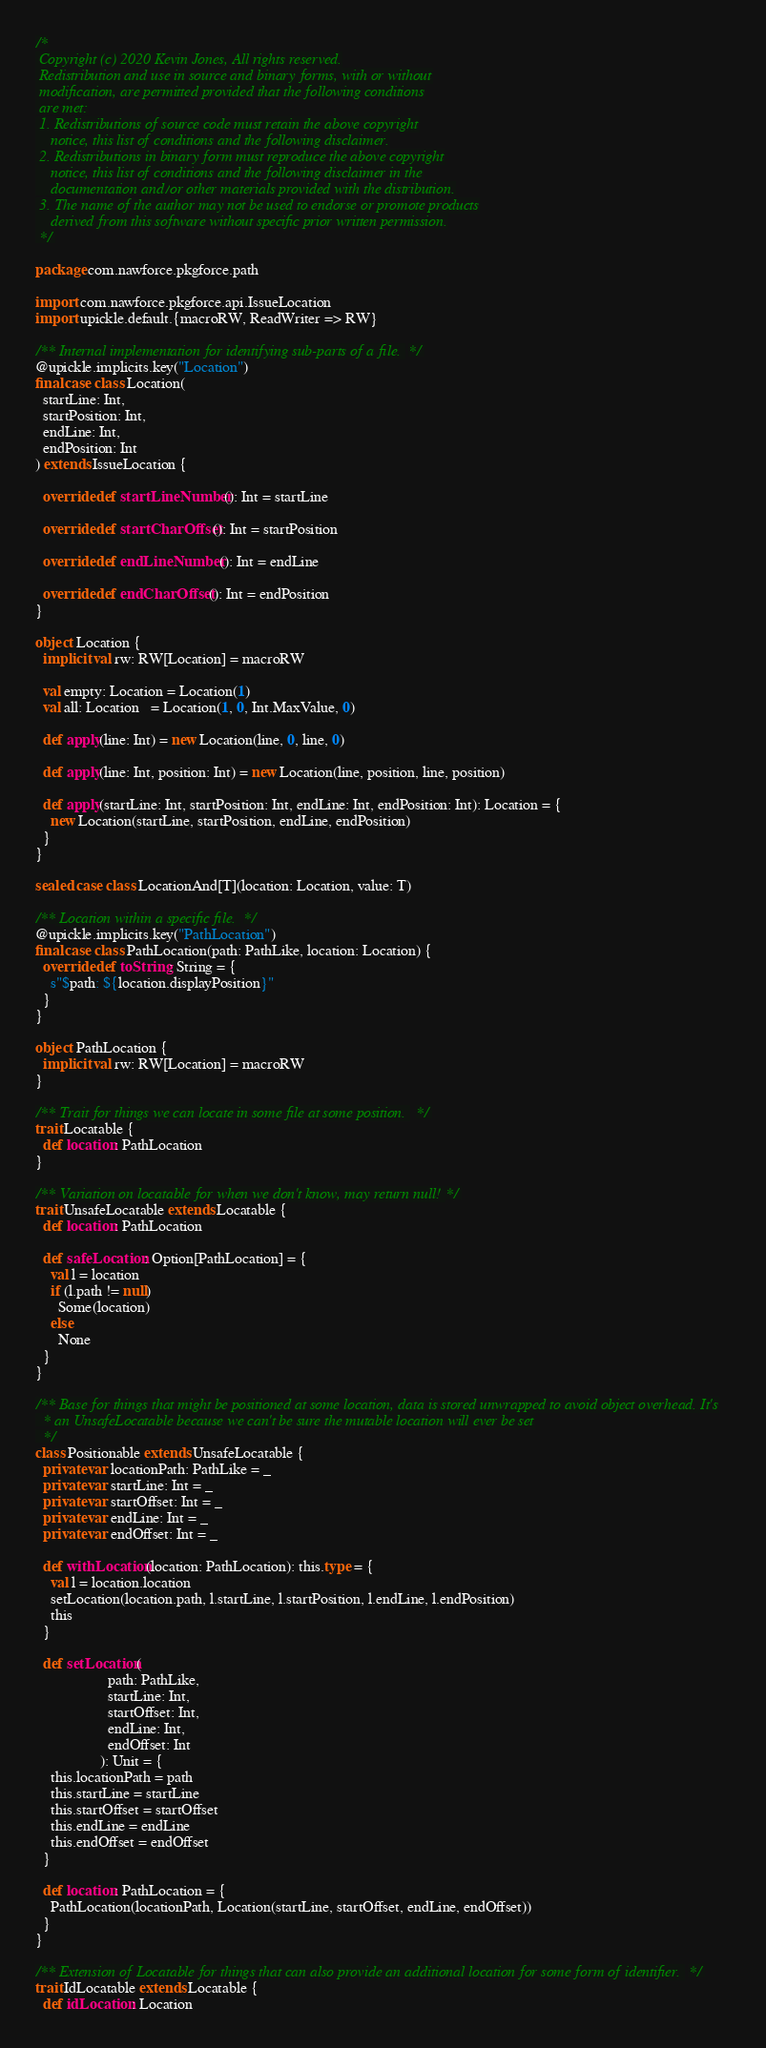Convert code to text. <code><loc_0><loc_0><loc_500><loc_500><_Scala_>/*
 Copyright (c) 2020 Kevin Jones, All rights reserved.
 Redistribution and use in source and binary forms, with or without
 modification, are permitted provided that the following conditions
 are met:
 1. Redistributions of source code must retain the above copyright
    notice, this list of conditions and the following disclaimer.
 2. Redistributions in binary form must reproduce the above copyright
    notice, this list of conditions and the following disclaimer in the
    documentation and/or other materials provided with the distribution.
 3. The name of the author may not be used to endorse or promote products
    derived from this software without specific prior written permission.
 */

package com.nawforce.pkgforce.path

import com.nawforce.pkgforce.api.IssueLocation
import upickle.default.{macroRW, ReadWriter => RW}

/** Internal implementation for identifying sub-parts of a file. */
@upickle.implicits.key("Location")
final case class Location(
  startLine: Int,
  startPosition: Int,
  endLine: Int,
  endPosition: Int
) extends IssueLocation {

  override def startLineNumber(): Int = startLine

  override def startCharOffset(): Int = startPosition

  override def endLineNumber(): Int = endLine

  override def endCharOffset(): Int = endPosition
}

object Location {
  implicit val rw: RW[Location] = macroRW

  val empty: Location = Location(1)
  val all: Location   = Location(1, 0, Int.MaxValue, 0)

  def apply(line: Int) = new Location(line, 0, line, 0)

  def apply(line: Int, position: Int) = new Location(line, position, line, position)

  def apply(startLine: Int, startPosition: Int, endLine: Int, endPosition: Int): Location = {
    new Location(startLine, startPosition, endLine, endPosition)
  }
}

sealed case class LocationAnd[T](location: Location, value: T)

/** Location within a specific file. */
@upickle.implicits.key("PathLocation")
final case class PathLocation(path: PathLike, location: Location) {
  override def toString: String = {
    s"$path: ${location.displayPosition}"
  }
}

object PathLocation {
  implicit val rw: RW[Location] = macroRW
}

/** Trait for things we can locate in some file at some position. */
trait Locatable {
  def location: PathLocation
}

/** Variation on locatable for when we don't know, may return null! */
trait UnsafeLocatable extends Locatable {
  def location: PathLocation

  def safeLocation: Option[PathLocation] = {
    val l = location
    if (l.path != null)
      Some(location)
    else
      None
  }
}

/** Base for things that might be positioned at some location, data is stored unwrapped to avoid object overhead. It's
  * an UnsafeLocatable because we can't be sure the mutable location will ever be set
  */
class Positionable extends UnsafeLocatable {
  private var locationPath: PathLike = _
  private var startLine: Int = _
  private var startOffset: Int = _
  private var endLine: Int = _
  private var endOffset: Int = _

  def withLocation(location: PathLocation): this.type = {
    val l = location.location
    setLocation(location.path, l.startLine, l.startPosition, l.endLine, l.endPosition)
    this
  }

  def setLocation(
                   path: PathLike,
                   startLine: Int,
                   startOffset: Int,
                   endLine: Int,
                   endOffset: Int
                 ): Unit = {
    this.locationPath = path
    this.startLine = startLine
    this.startOffset = startOffset
    this.endLine = endLine
    this.endOffset = endOffset
  }

  def location: PathLocation = {
    PathLocation(locationPath, Location(startLine, startOffset, endLine, endOffset))
  }
}

/** Extension of Locatable for things that can also provide an additional location for some form of identifier. */
trait IdLocatable extends Locatable {
  def idLocation: Location</code> 